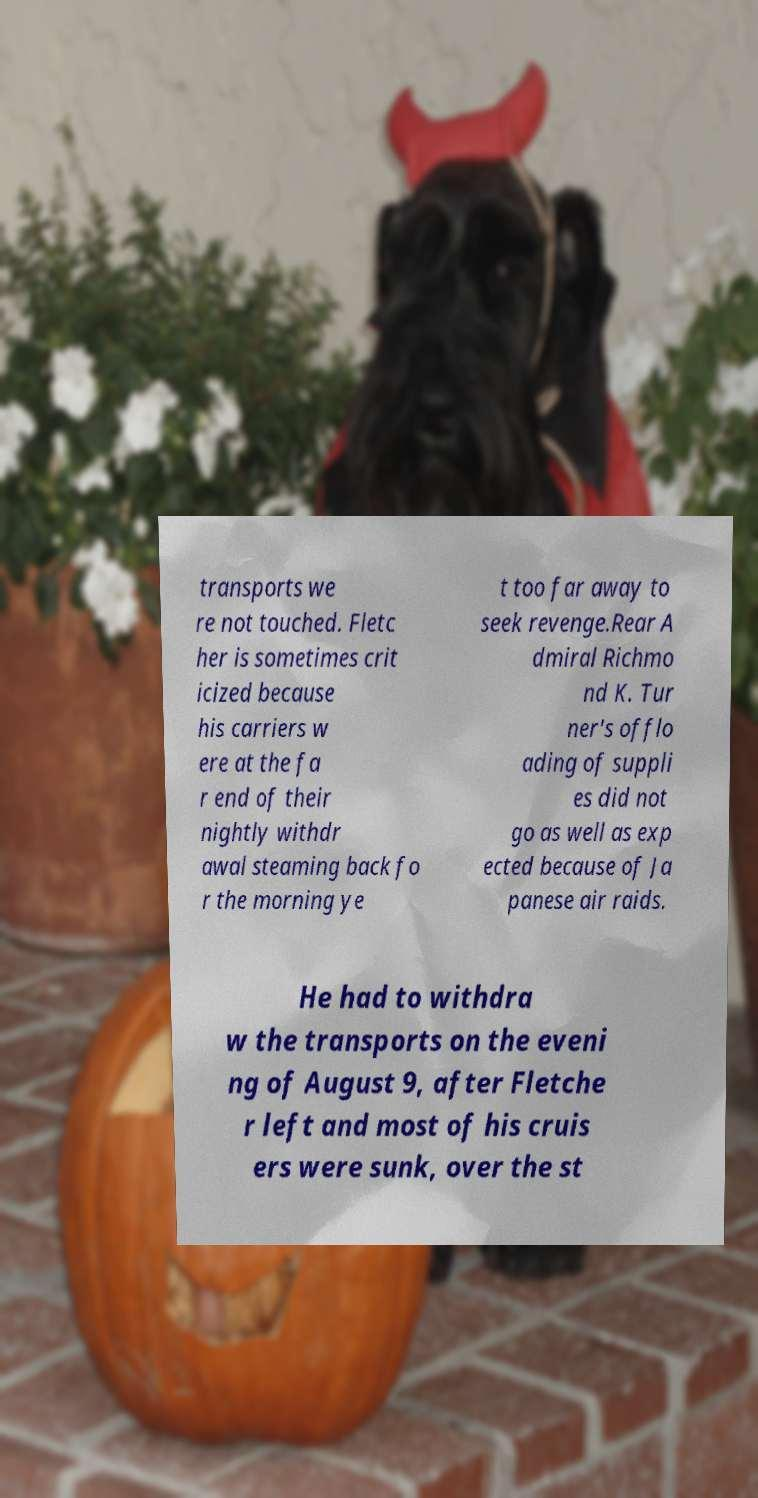For documentation purposes, I need the text within this image transcribed. Could you provide that? transports we re not touched. Fletc her is sometimes crit icized because his carriers w ere at the fa r end of their nightly withdr awal steaming back fo r the morning ye t too far away to seek revenge.Rear A dmiral Richmo nd K. Tur ner's offlo ading of suppli es did not go as well as exp ected because of Ja panese air raids. He had to withdra w the transports on the eveni ng of August 9, after Fletche r left and most of his cruis ers were sunk, over the st 